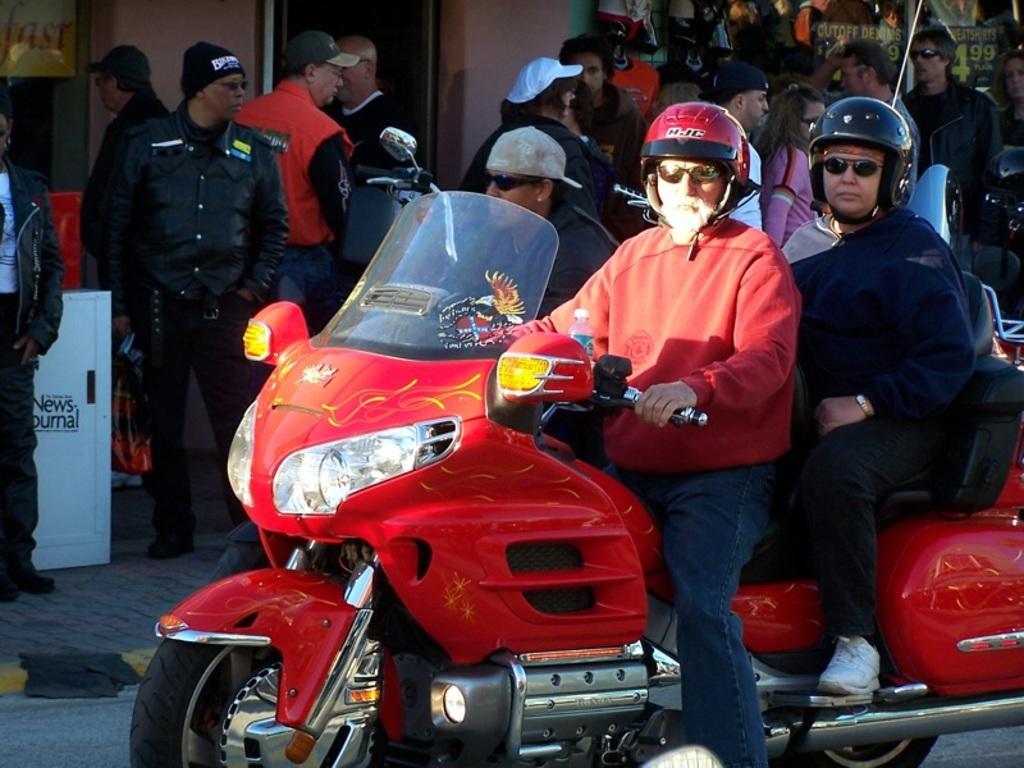Could you give a brief overview of what you see in this image? There are two people who are sitting on a motorcycle. They are wearing a helmet on their head and in the background there are group of people. 